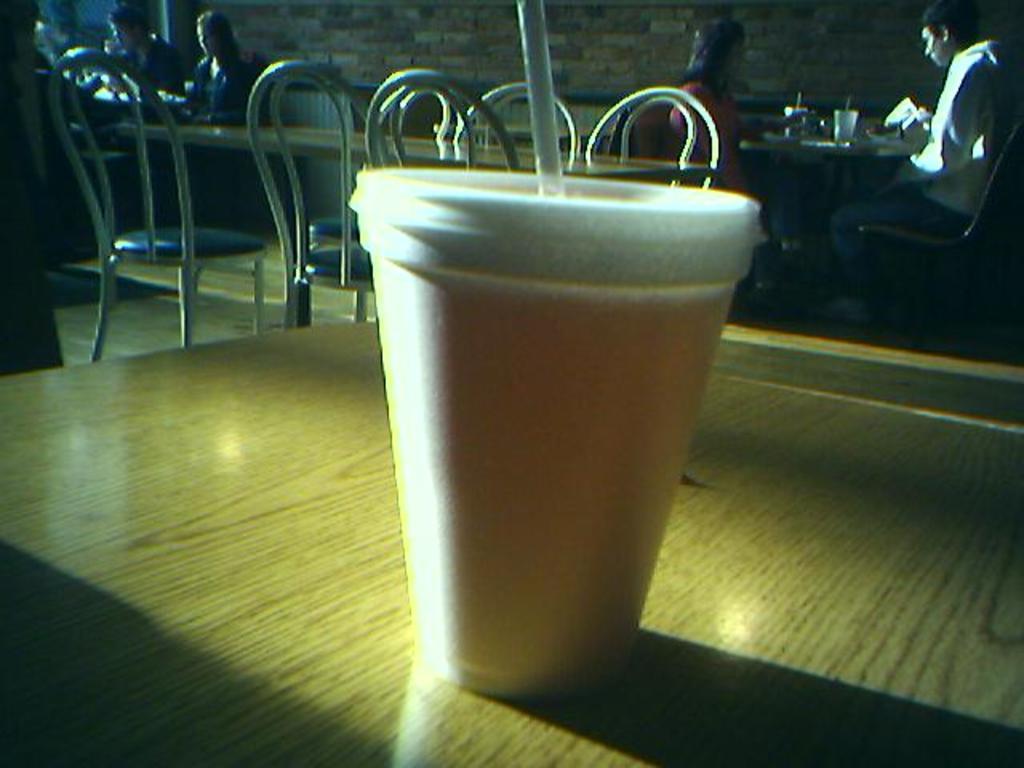Can you describe this image briefly? In the foreground we can see the glass with straw on the wooden table. In the background, we can see four persons sitting on the chairs. Here we can see the wooden tables and chairs on the floor. In the background, we can see the brick wall. 